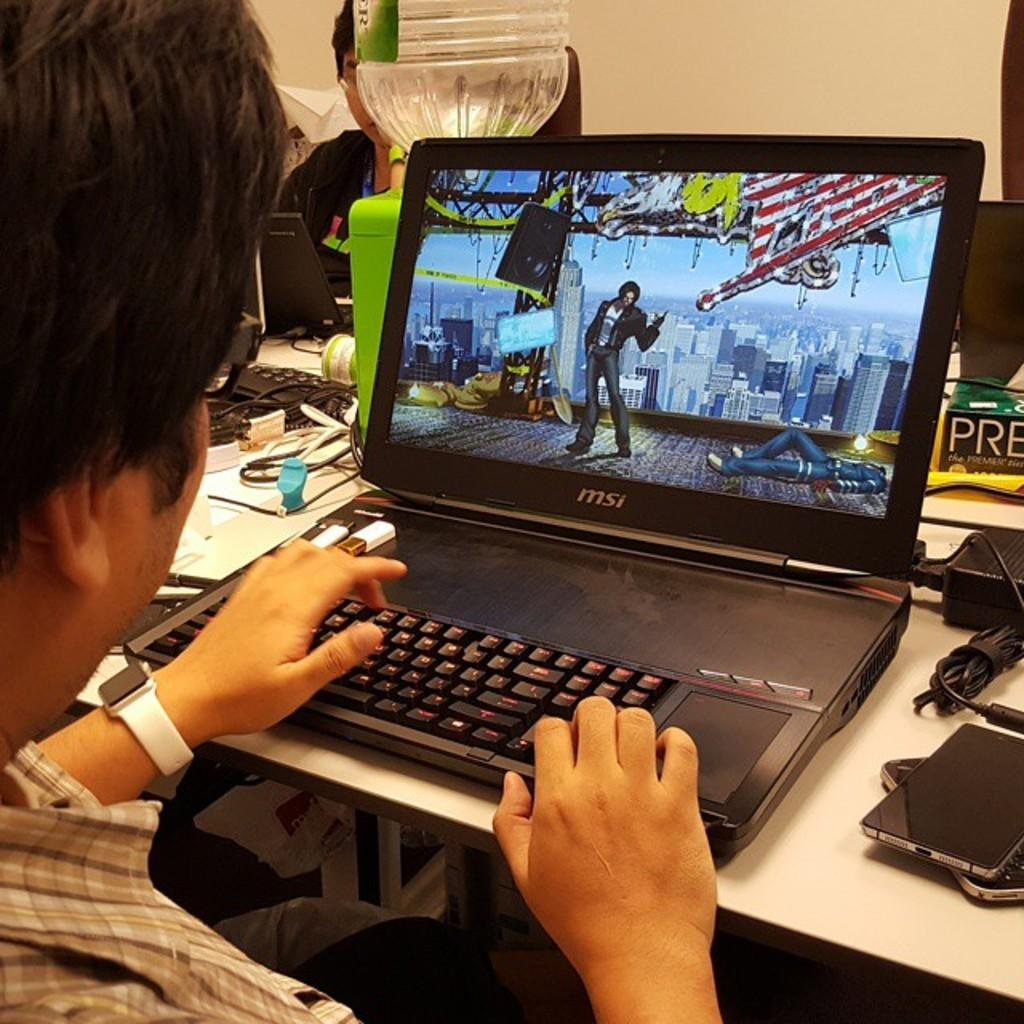<image>
Create a compact narrative representing the image presented. A person playing a game on a laptop which has the letters MSI on it. 